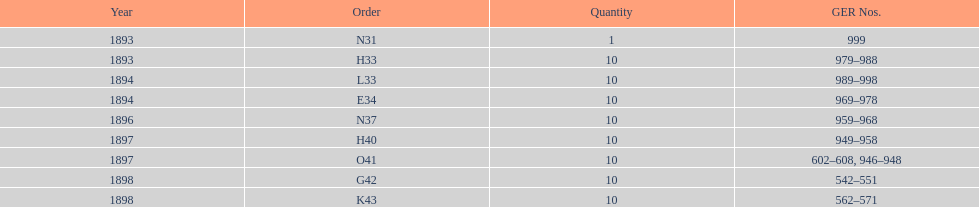How many years are listed? 5. 